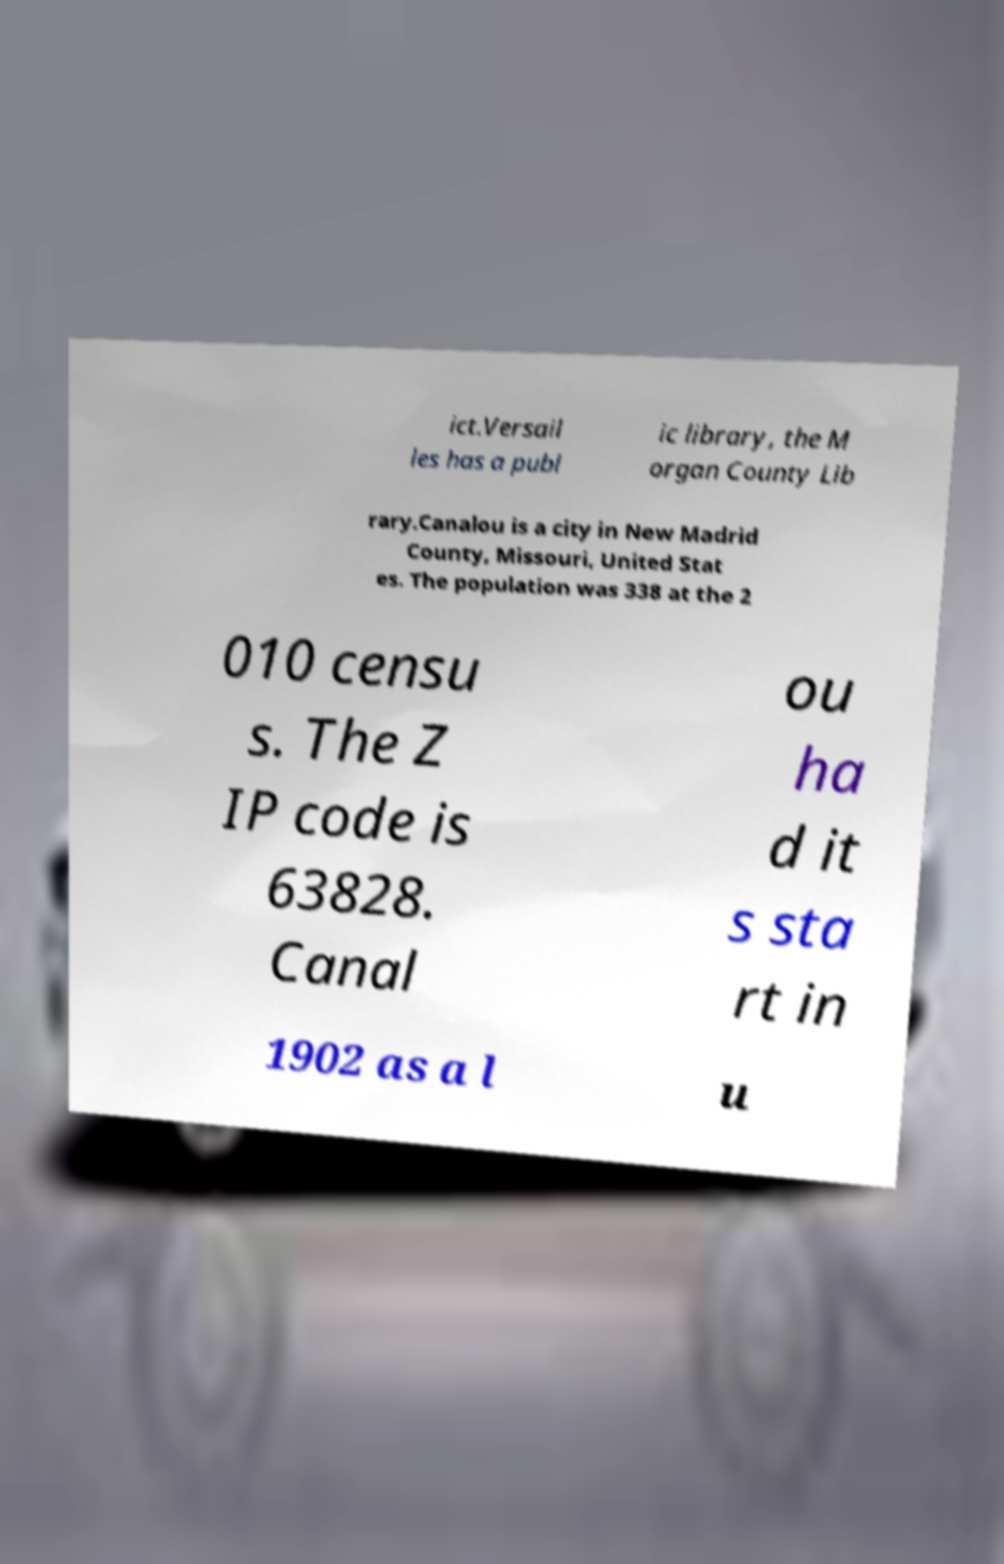Could you assist in decoding the text presented in this image and type it out clearly? ict.Versail les has a publ ic library, the M organ County Lib rary.Canalou is a city in New Madrid County, Missouri, United Stat es. The population was 338 at the 2 010 censu s. The Z IP code is 63828. Canal ou ha d it s sta rt in 1902 as a l u 